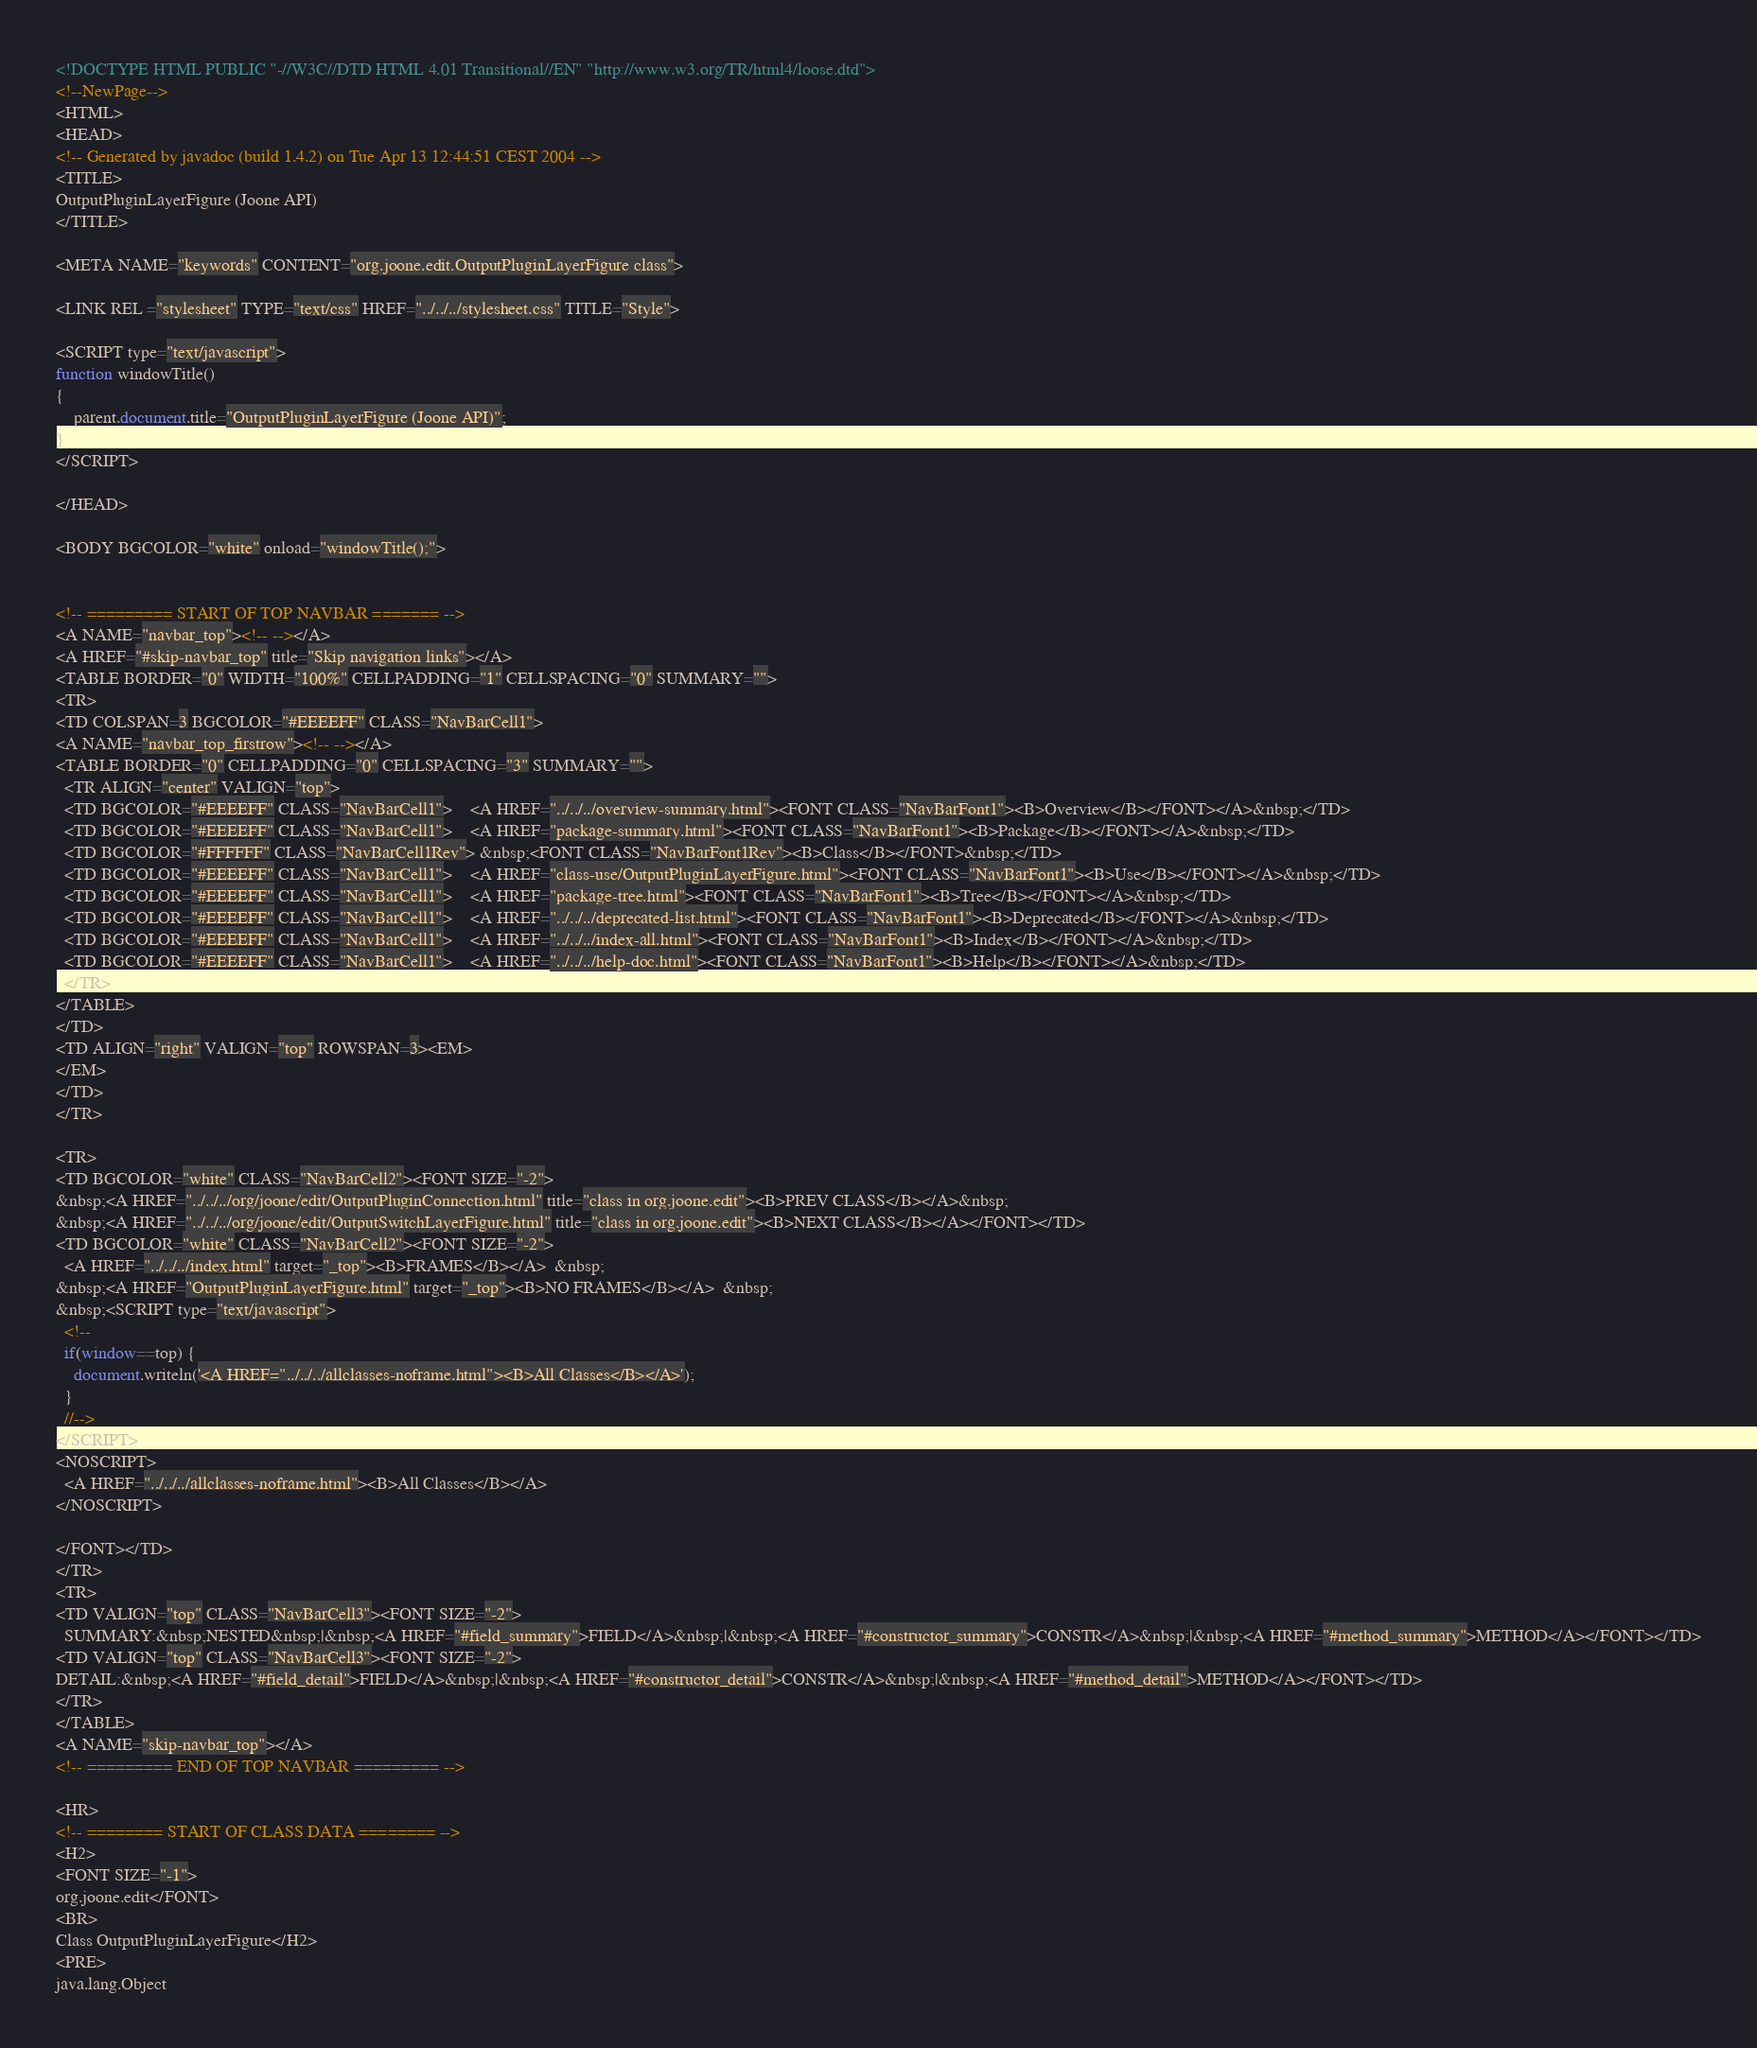<code> <loc_0><loc_0><loc_500><loc_500><_HTML_><!DOCTYPE HTML PUBLIC "-//W3C//DTD HTML 4.01 Transitional//EN" "http://www.w3.org/TR/html4/loose.dtd">
<!--NewPage-->
<HTML>
<HEAD>
<!-- Generated by javadoc (build 1.4.2) on Tue Apr 13 12:44:51 CEST 2004 -->
<TITLE>
OutputPluginLayerFigure (Joone API)
</TITLE>

<META NAME="keywords" CONTENT="org.joone.edit.OutputPluginLayerFigure class">

<LINK REL ="stylesheet" TYPE="text/css" HREF="../../../stylesheet.css" TITLE="Style">

<SCRIPT type="text/javascript">
function windowTitle()
{
    parent.document.title="OutputPluginLayerFigure (Joone API)";
}
</SCRIPT>

</HEAD>

<BODY BGCOLOR="white" onload="windowTitle();">


<!-- ========= START OF TOP NAVBAR ======= -->
<A NAME="navbar_top"><!-- --></A>
<A HREF="#skip-navbar_top" title="Skip navigation links"></A>
<TABLE BORDER="0" WIDTH="100%" CELLPADDING="1" CELLSPACING="0" SUMMARY="">
<TR>
<TD COLSPAN=3 BGCOLOR="#EEEEFF" CLASS="NavBarCell1">
<A NAME="navbar_top_firstrow"><!-- --></A>
<TABLE BORDER="0" CELLPADDING="0" CELLSPACING="3" SUMMARY="">
  <TR ALIGN="center" VALIGN="top">
  <TD BGCOLOR="#EEEEFF" CLASS="NavBarCell1">    <A HREF="../../../overview-summary.html"><FONT CLASS="NavBarFont1"><B>Overview</B></FONT></A>&nbsp;</TD>
  <TD BGCOLOR="#EEEEFF" CLASS="NavBarCell1">    <A HREF="package-summary.html"><FONT CLASS="NavBarFont1"><B>Package</B></FONT></A>&nbsp;</TD>
  <TD BGCOLOR="#FFFFFF" CLASS="NavBarCell1Rev"> &nbsp;<FONT CLASS="NavBarFont1Rev"><B>Class</B></FONT>&nbsp;</TD>
  <TD BGCOLOR="#EEEEFF" CLASS="NavBarCell1">    <A HREF="class-use/OutputPluginLayerFigure.html"><FONT CLASS="NavBarFont1"><B>Use</B></FONT></A>&nbsp;</TD>
  <TD BGCOLOR="#EEEEFF" CLASS="NavBarCell1">    <A HREF="package-tree.html"><FONT CLASS="NavBarFont1"><B>Tree</B></FONT></A>&nbsp;</TD>
  <TD BGCOLOR="#EEEEFF" CLASS="NavBarCell1">    <A HREF="../../../deprecated-list.html"><FONT CLASS="NavBarFont1"><B>Deprecated</B></FONT></A>&nbsp;</TD>
  <TD BGCOLOR="#EEEEFF" CLASS="NavBarCell1">    <A HREF="../../../index-all.html"><FONT CLASS="NavBarFont1"><B>Index</B></FONT></A>&nbsp;</TD>
  <TD BGCOLOR="#EEEEFF" CLASS="NavBarCell1">    <A HREF="../../../help-doc.html"><FONT CLASS="NavBarFont1"><B>Help</B></FONT></A>&nbsp;</TD>
  </TR>
</TABLE>
</TD>
<TD ALIGN="right" VALIGN="top" ROWSPAN=3><EM>
</EM>
</TD>
</TR>

<TR>
<TD BGCOLOR="white" CLASS="NavBarCell2"><FONT SIZE="-2">
&nbsp;<A HREF="../../../org/joone/edit/OutputPluginConnection.html" title="class in org.joone.edit"><B>PREV CLASS</B></A>&nbsp;
&nbsp;<A HREF="../../../org/joone/edit/OutputSwitchLayerFigure.html" title="class in org.joone.edit"><B>NEXT CLASS</B></A></FONT></TD>
<TD BGCOLOR="white" CLASS="NavBarCell2"><FONT SIZE="-2">
  <A HREF="../../../index.html" target="_top"><B>FRAMES</B></A>  &nbsp;
&nbsp;<A HREF="OutputPluginLayerFigure.html" target="_top"><B>NO FRAMES</B></A>  &nbsp;
&nbsp;<SCRIPT type="text/javascript">
  <!--
  if(window==top) {
    document.writeln('<A HREF="../../../allclasses-noframe.html"><B>All Classes</B></A>');
  }
  //-->
</SCRIPT>
<NOSCRIPT>
  <A HREF="../../../allclasses-noframe.html"><B>All Classes</B></A>
</NOSCRIPT>

</FONT></TD>
</TR>
<TR>
<TD VALIGN="top" CLASS="NavBarCell3"><FONT SIZE="-2">
  SUMMARY:&nbsp;NESTED&nbsp;|&nbsp;<A HREF="#field_summary">FIELD</A>&nbsp;|&nbsp;<A HREF="#constructor_summary">CONSTR</A>&nbsp;|&nbsp;<A HREF="#method_summary">METHOD</A></FONT></TD>
<TD VALIGN="top" CLASS="NavBarCell3"><FONT SIZE="-2">
DETAIL:&nbsp;<A HREF="#field_detail">FIELD</A>&nbsp;|&nbsp;<A HREF="#constructor_detail">CONSTR</A>&nbsp;|&nbsp;<A HREF="#method_detail">METHOD</A></FONT></TD>
</TR>
</TABLE>
<A NAME="skip-navbar_top"></A>
<!-- ========= END OF TOP NAVBAR ========= -->

<HR>
<!-- ======== START OF CLASS DATA ======== -->
<H2>
<FONT SIZE="-1">
org.joone.edit</FONT>
<BR>
Class OutputPluginLayerFigure</H2>
<PRE>
java.lang.Object</code> 